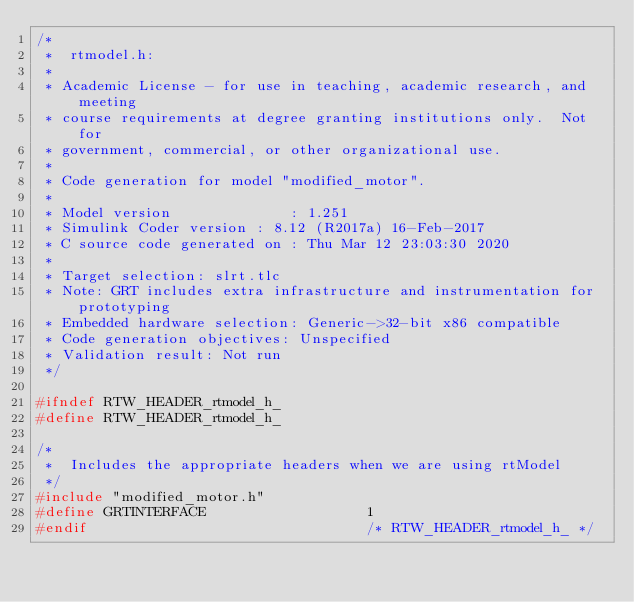Convert code to text. <code><loc_0><loc_0><loc_500><loc_500><_C_>/*
 *  rtmodel.h:
 *
 * Academic License - for use in teaching, academic research, and meeting
 * course requirements at degree granting institutions only.  Not for
 * government, commercial, or other organizational use.
 *
 * Code generation for model "modified_motor".
 *
 * Model version              : 1.251
 * Simulink Coder version : 8.12 (R2017a) 16-Feb-2017
 * C source code generated on : Thu Mar 12 23:03:30 2020
 *
 * Target selection: slrt.tlc
 * Note: GRT includes extra infrastructure and instrumentation for prototyping
 * Embedded hardware selection: Generic->32-bit x86 compatible
 * Code generation objectives: Unspecified
 * Validation result: Not run
 */

#ifndef RTW_HEADER_rtmodel_h_
#define RTW_HEADER_rtmodel_h_

/*
 *  Includes the appropriate headers when we are using rtModel
 */
#include "modified_motor.h"
#define GRTINTERFACE                   1
#endif                                 /* RTW_HEADER_rtmodel_h_ */
</code> 